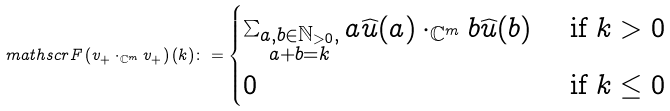<formula> <loc_0><loc_0><loc_500><loc_500>\ m a t h s c r { F } \left ( v _ { + } \cdot _ { \mathbb { C } ^ { m } } v _ { + } \right ) ( k ) \colon = \begin{cases} \sum _ { \substack { a , b \in \mathbb { N } _ { > 0 } , \\ a + b = k } } a \widehat { u } ( a ) \cdot _ { \mathbb { C } ^ { m } } b \widehat { u } ( b ) & \text { if } k > 0 \\ 0 & \text { if } k \leq 0 \end{cases}</formula> 